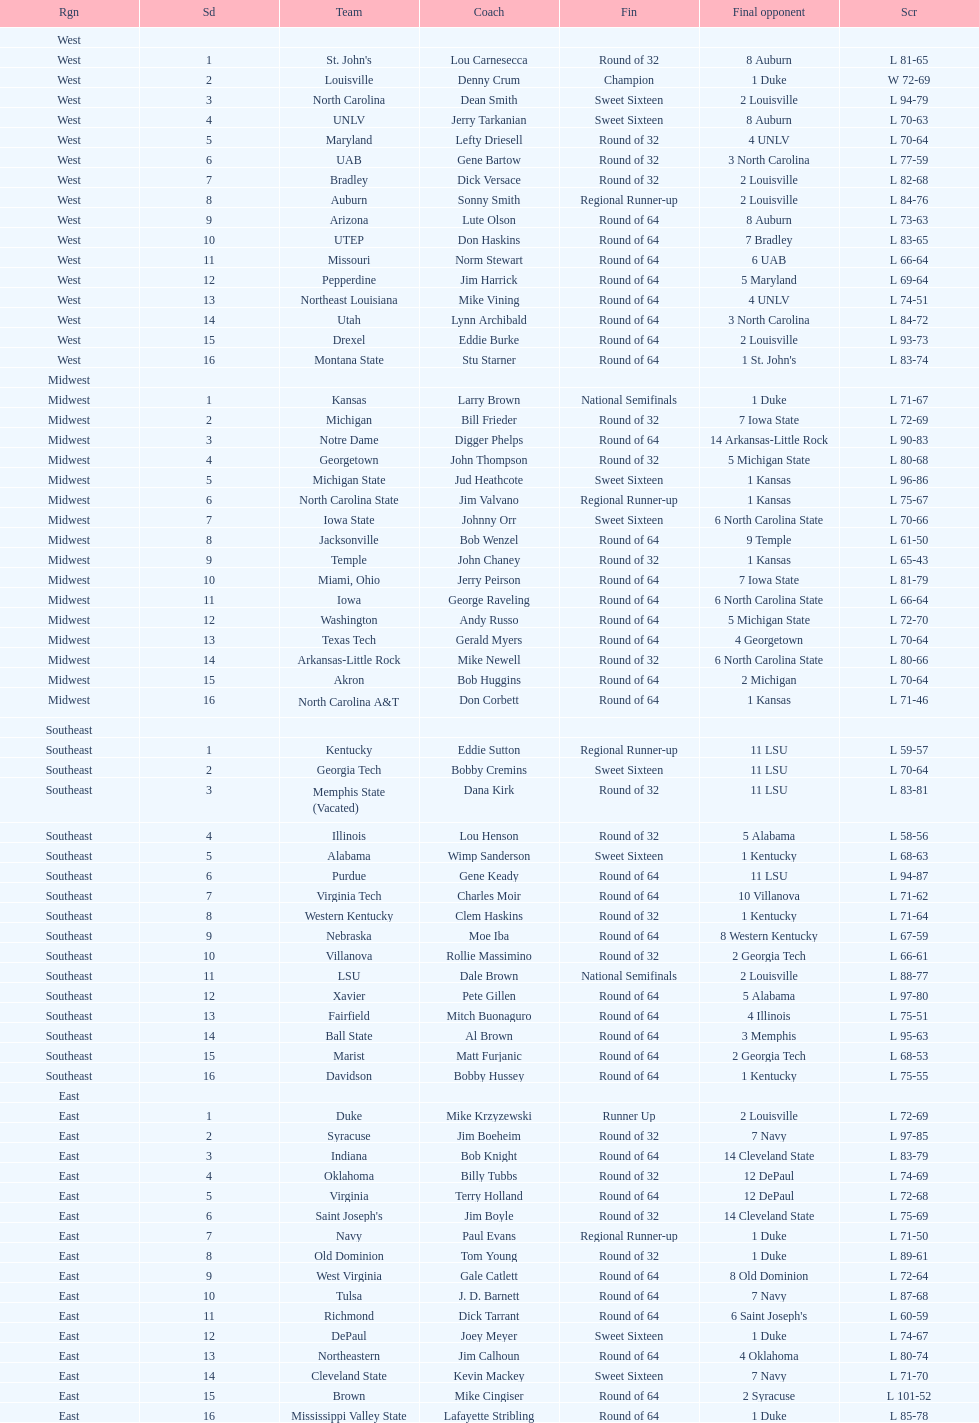Who was the only champion? Louisville. 